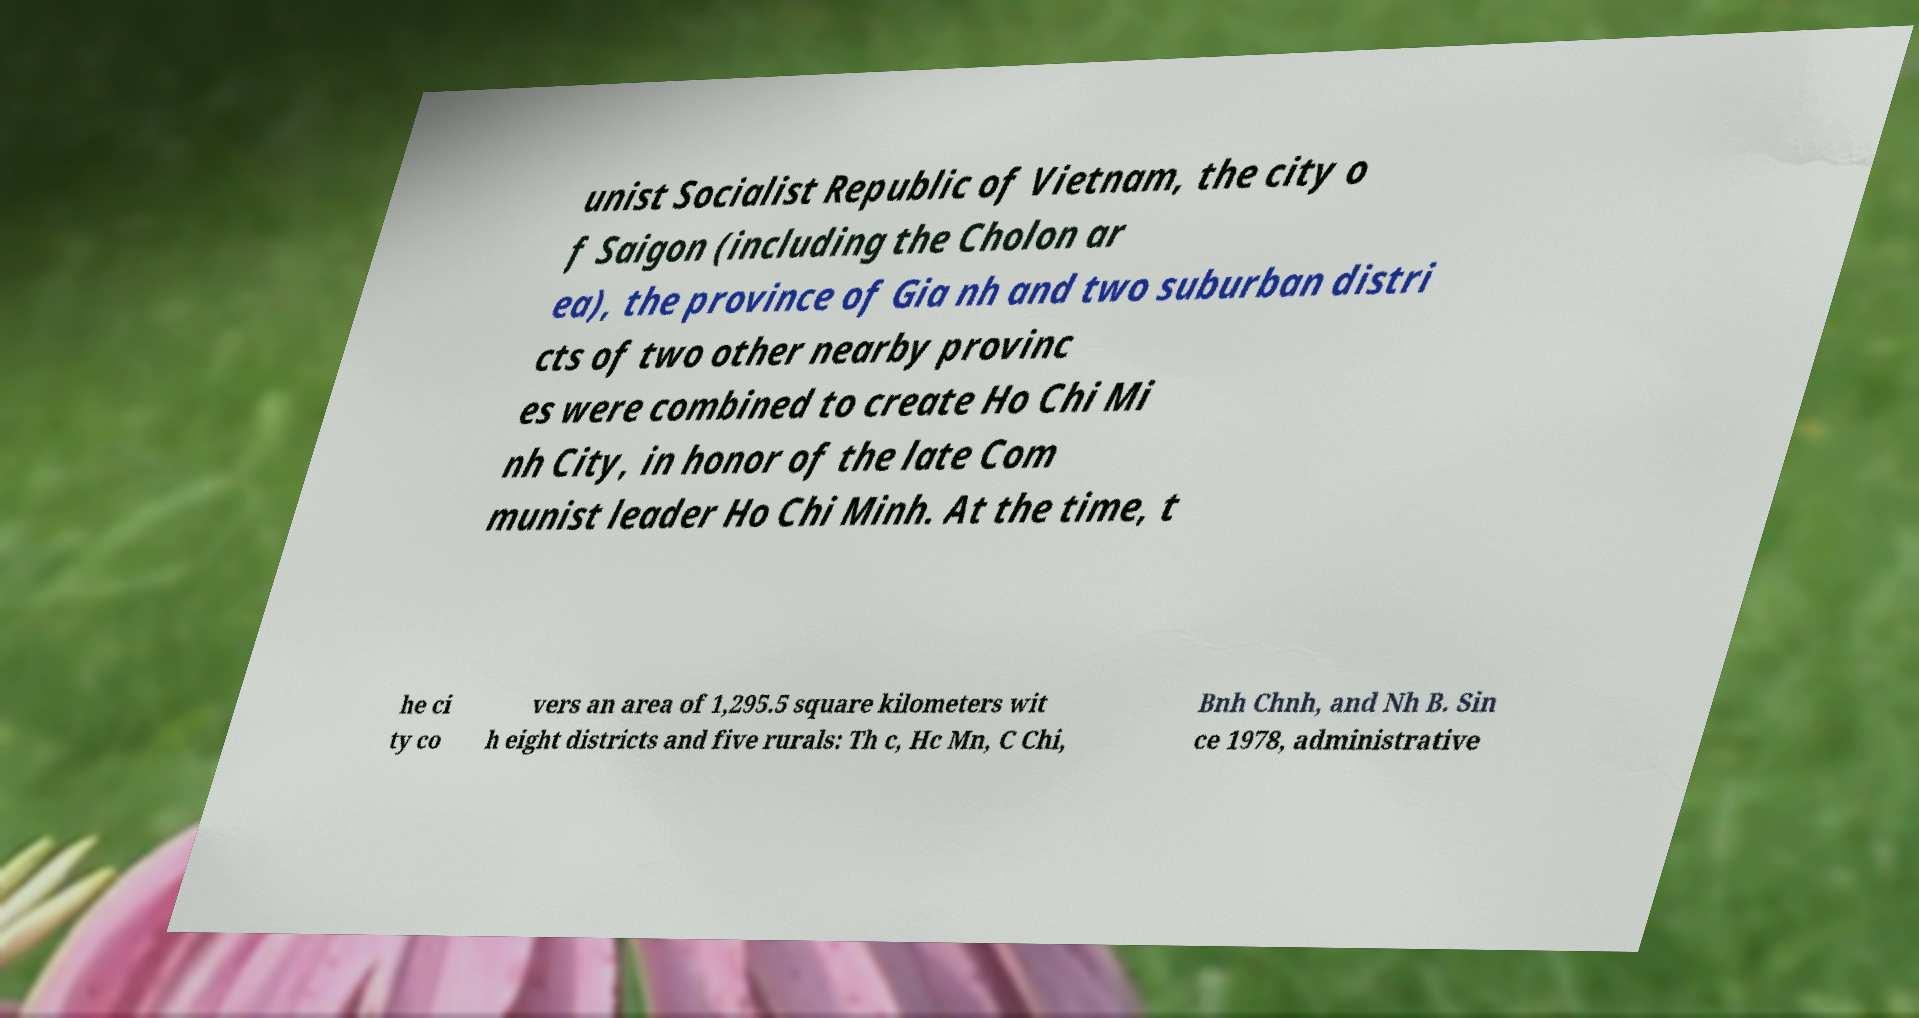Could you assist in decoding the text presented in this image and type it out clearly? unist Socialist Republic of Vietnam, the city o f Saigon (including the Cholon ar ea), the province of Gia nh and two suburban distri cts of two other nearby provinc es were combined to create Ho Chi Mi nh City, in honor of the late Com munist leader Ho Chi Minh. At the time, t he ci ty co vers an area of 1,295.5 square kilometers wit h eight districts and five rurals: Th c, Hc Mn, C Chi, Bnh Chnh, and Nh B. Sin ce 1978, administrative 